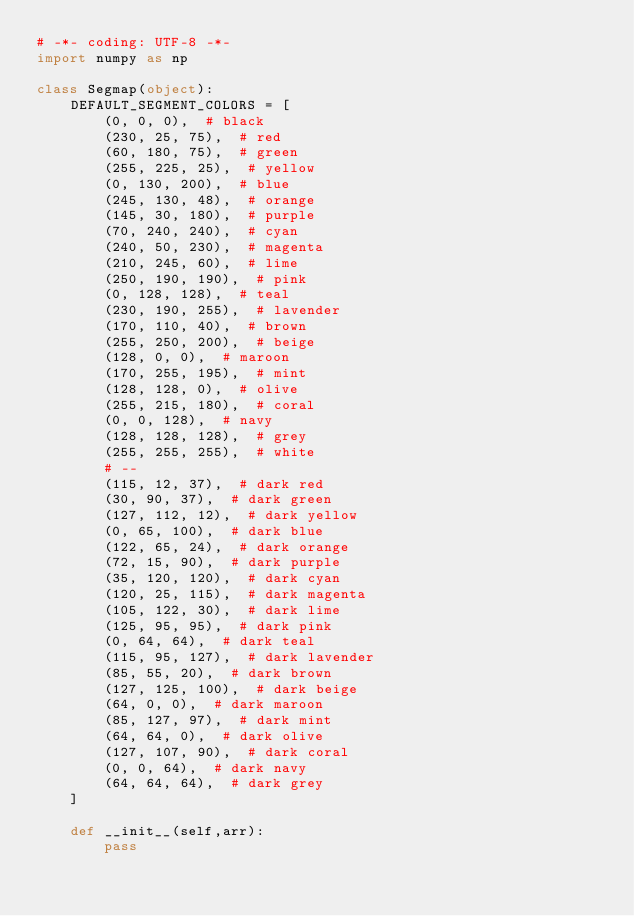<code> <loc_0><loc_0><loc_500><loc_500><_Python_># -*- coding: UTF-8 -*-
import numpy as np

class Segmap(object):
    DEFAULT_SEGMENT_COLORS = [
        (0, 0, 0),  # black
        (230, 25, 75),  # red
        (60, 180, 75),  # green
        (255, 225, 25),  # yellow
        (0, 130, 200),  # blue
        (245, 130, 48),  # orange
        (145, 30, 180),  # purple
        (70, 240, 240),  # cyan
        (240, 50, 230),  # magenta
        (210, 245, 60),  # lime
        (250, 190, 190),  # pink
        (0, 128, 128),  # teal
        (230, 190, 255),  # lavender
        (170, 110, 40),  # brown
        (255, 250, 200),  # beige
        (128, 0, 0),  # maroon
        (170, 255, 195),  # mint
        (128, 128, 0),  # olive
        (255, 215, 180),  # coral
        (0, 0, 128),  # navy
        (128, 128, 128),  # grey
        (255, 255, 255),  # white
        # --
        (115, 12, 37),  # dark red
        (30, 90, 37),  # dark green
        (127, 112, 12),  # dark yellow
        (0, 65, 100),  # dark blue
        (122, 65, 24),  # dark orange
        (72, 15, 90),  # dark purple
        (35, 120, 120),  # dark cyan
        (120, 25, 115),  # dark magenta
        (105, 122, 30),  # dark lime
        (125, 95, 95),  # dark pink
        (0, 64, 64),  # dark teal
        (115, 95, 127),  # dark lavender
        (85, 55, 20),  # dark brown
        (127, 125, 100),  # dark beige
        (64, 0, 0),  # dark maroon
        (85, 127, 97),  # dark mint
        (64, 64, 0),  # dark olive
        (127, 107, 90),  # dark coral
        (0, 0, 64),  # dark navy
        (64, 64, 64),  # dark grey
    ]

    def __init__(self,arr):
        pass




</code> 